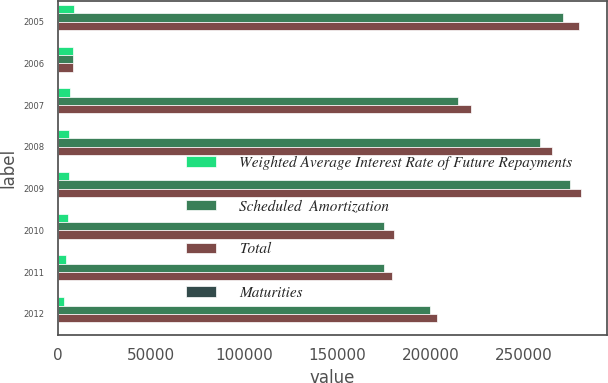Convert chart to OTSL. <chart><loc_0><loc_0><loc_500><loc_500><stacked_bar_chart><ecel><fcel>2005<fcel>2006<fcel>2007<fcel>2008<fcel>2009<fcel>2010<fcel>2011<fcel>2012<nl><fcel>Weighted Average Interest Rate of Future Repayments<fcel>8686<fcel>8318<fcel>6891<fcel>6031<fcel>5867<fcel>5313<fcel>4647<fcel>3332<nl><fcel>Scheduled  Amortization<fcel>270980<fcel>8502<fcel>214615<fcel>259028<fcel>275000<fcel>175000<fcel>175000<fcel>200000<nl><fcel>Total<fcel>279666<fcel>8502<fcel>221506<fcel>265059<fcel>280867<fcel>180313<fcel>179647<fcel>203332<nl><fcel>Maturities<fcel>6.04<fcel>4.29<fcel>5.51<fcel>4.92<fcel>7.37<fcel>5.39<fcel>6.94<fcel>5.86<nl></chart> 